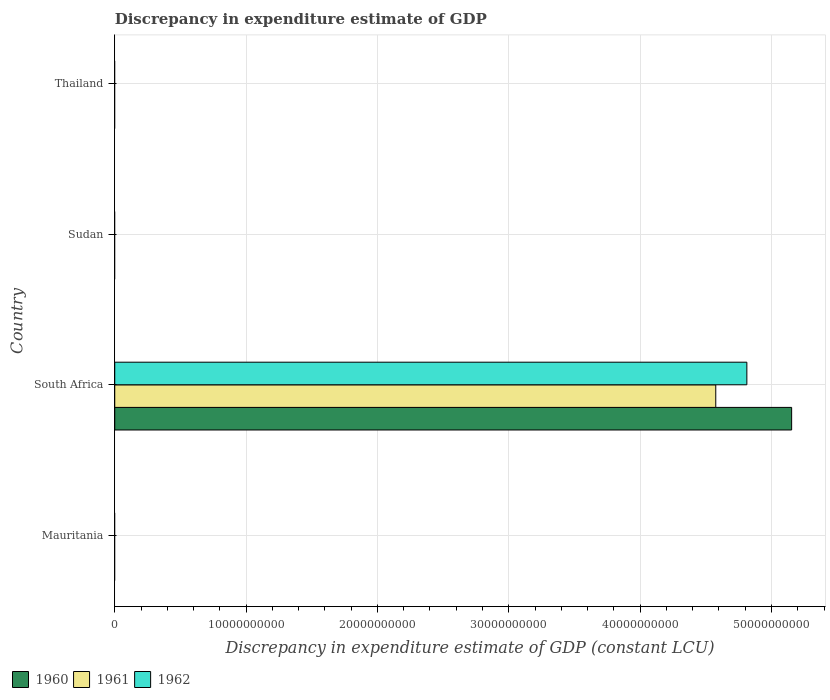Are the number of bars per tick equal to the number of legend labels?
Make the answer very short. No. How many bars are there on the 1st tick from the bottom?
Your response must be concise. 0. What is the label of the 1st group of bars from the top?
Provide a short and direct response. Thailand. What is the discrepancy in expenditure estimate of GDP in 1962 in South Africa?
Offer a very short reply. 4.81e+1. Across all countries, what is the maximum discrepancy in expenditure estimate of GDP in 1962?
Make the answer very short. 4.81e+1. Across all countries, what is the minimum discrepancy in expenditure estimate of GDP in 1962?
Make the answer very short. 0. In which country was the discrepancy in expenditure estimate of GDP in 1962 maximum?
Your response must be concise. South Africa. What is the total discrepancy in expenditure estimate of GDP in 1962 in the graph?
Keep it short and to the point. 4.81e+1. What is the difference between the discrepancy in expenditure estimate of GDP in 1960 in Sudan and the discrepancy in expenditure estimate of GDP in 1961 in South Africa?
Provide a short and direct response. -4.58e+1. What is the average discrepancy in expenditure estimate of GDP in 1962 per country?
Offer a terse response. 1.20e+1. What is the difference between the discrepancy in expenditure estimate of GDP in 1961 and discrepancy in expenditure estimate of GDP in 1960 in South Africa?
Keep it short and to the point. -5.78e+09. In how many countries, is the discrepancy in expenditure estimate of GDP in 1962 greater than 20000000000 LCU?
Give a very brief answer. 1. What is the difference between the highest and the lowest discrepancy in expenditure estimate of GDP in 1962?
Your answer should be very brief. 4.81e+1. Is it the case that in every country, the sum of the discrepancy in expenditure estimate of GDP in 1960 and discrepancy in expenditure estimate of GDP in 1961 is greater than the discrepancy in expenditure estimate of GDP in 1962?
Offer a very short reply. No. Are all the bars in the graph horizontal?
Ensure brevity in your answer.  Yes. Are the values on the major ticks of X-axis written in scientific E-notation?
Your answer should be very brief. No. Where does the legend appear in the graph?
Offer a very short reply. Bottom left. How many legend labels are there?
Give a very brief answer. 3. What is the title of the graph?
Your response must be concise. Discrepancy in expenditure estimate of GDP. Does "1970" appear as one of the legend labels in the graph?
Your answer should be very brief. No. What is the label or title of the X-axis?
Ensure brevity in your answer.  Discrepancy in expenditure estimate of GDP (constant LCU). What is the label or title of the Y-axis?
Make the answer very short. Country. What is the Discrepancy in expenditure estimate of GDP (constant LCU) of 1960 in Mauritania?
Ensure brevity in your answer.  0. What is the Discrepancy in expenditure estimate of GDP (constant LCU) in 1962 in Mauritania?
Give a very brief answer. 0. What is the Discrepancy in expenditure estimate of GDP (constant LCU) of 1960 in South Africa?
Your answer should be very brief. 5.15e+1. What is the Discrepancy in expenditure estimate of GDP (constant LCU) in 1961 in South Africa?
Make the answer very short. 4.58e+1. What is the Discrepancy in expenditure estimate of GDP (constant LCU) in 1962 in South Africa?
Ensure brevity in your answer.  4.81e+1. What is the Discrepancy in expenditure estimate of GDP (constant LCU) in 1960 in Sudan?
Provide a succinct answer. 0. What is the Discrepancy in expenditure estimate of GDP (constant LCU) of 1961 in Sudan?
Make the answer very short. 0. What is the Discrepancy in expenditure estimate of GDP (constant LCU) in 1962 in Sudan?
Offer a very short reply. 0. What is the Discrepancy in expenditure estimate of GDP (constant LCU) of 1961 in Thailand?
Give a very brief answer. 0. What is the Discrepancy in expenditure estimate of GDP (constant LCU) in 1962 in Thailand?
Ensure brevity in your answer.  0. Across all countries, what is the maximum Discrepancy in expenditure estimate of GDP (constant LCU) in 1960?
Offer a terse response. 5.15e+1. Across all countries, what is the maximum Discrepancy in expenditure estimate of GDP (constant LCU) of 1961?
Provide a succinct answer. 4.58e+1. Across all countries, what is the maximum Discrepancy in expenditure estimate of GDP (constant LCU) of 1962?
Give a very brief answer. 4.81e+1. Across all countries, what is the minimum Discrepancy in expenditure estimate of GDP (constant LCU) of 1960?
Offer a very short reply. 0. Across all countries, what is the minimum Discrepancy in expenditure estimate of GDP (constant LCU) of 1961?
Your answer should be compact. 0. What is the total Discrepancy in expenditure estimate of GDP (constant LCU) in 1960 in the graph?
Ensure brevity in your answer.  5.15e+1. What is the total Discrepancy in expenditure estimate of GDP (constant LCU) of 1961 in the graph?
Your response must be concise. 4.58e+1. What is the total Discrepancy in expenditure estimate of GDP (constant LCU) in 1962 in the graph?
Your answer should be very brief. 4.81e+1. What is the average Discrepancy in expenditure estimate of GDP (constant LCU) in 1960 per country?
Offer a very short reply. 1.29e+1. What is the average Discrepancy in expenditure estimate of GDP (constant LCU) of 1961 per country?
Provide a short and direct response. 1.14e+1. What is the average Discrepancy in expenditure estimate of GDP (constant LCU) in 1962 per country?
Your response must be concise. 1.20e+1. What is the difference between the Discrepancy in expenditure estimate of GDP (constant LCU) of 1960 and Discrepancy in expenditure estimate of GDP (constant LCU) of 1961 in South Africa?
Offer a very short reply. 5.78e+09. What is the difference between the Discrepancy in expenditure estimate of GDP (constant LCU) in 1960 and Discrepancy in expenditure estimate of GDP (constant LCU) in 1962 in South Africa?
Your answer should be very brief. 3.41e+09. What is the difference between the Discrepancy in expenditure estimate of GDP (constant LCU) of 1961 and Discrepancy in expenditure estimate of GDP (constant LCU) of 1962 in South Africa?
Make the answer very short. -2.37e+09. What is the difference between the highest and the lowest Discrepancy in expenditure estimate of GDP (constant LCU) of 1960?
Offer a terse response. 5.15e+1. What is the difference between the highest and the lowest Discrepancy in expenditure estimate of GDP (constant LCU) in 1961?
Your answer should be very brief. 4.58e+1. What is the difference between the highest and the lowest Discrepancy in expenditure estimate of GDP (constant LCU) in 1962?
Provide a short and direct response. 4.81e+1. 